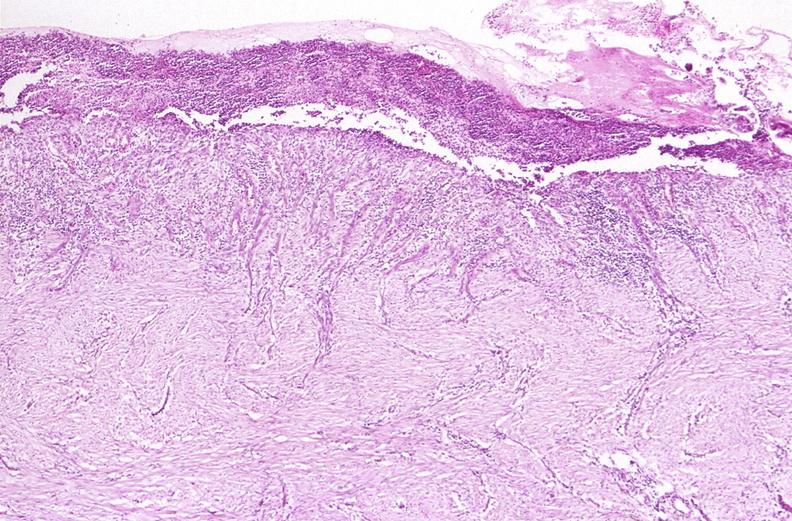does syndactyly show stomach, chronic peptic ulcer?
Answer the question using a single word or phrase. No 